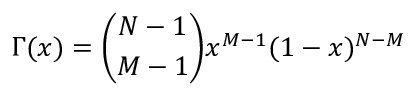<formula> <loc_0><loc_0><loc_500><loc_500>\Gamma ( x ) = \binom { N - 1 } { M - 1 } x ^ { M - 1 } ( 1 - x ) ^ { N - M }</formula> 